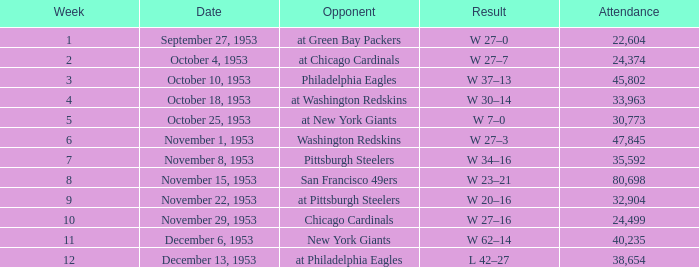What is the average week number of all the matches where less than 22,604 people attended? None. 